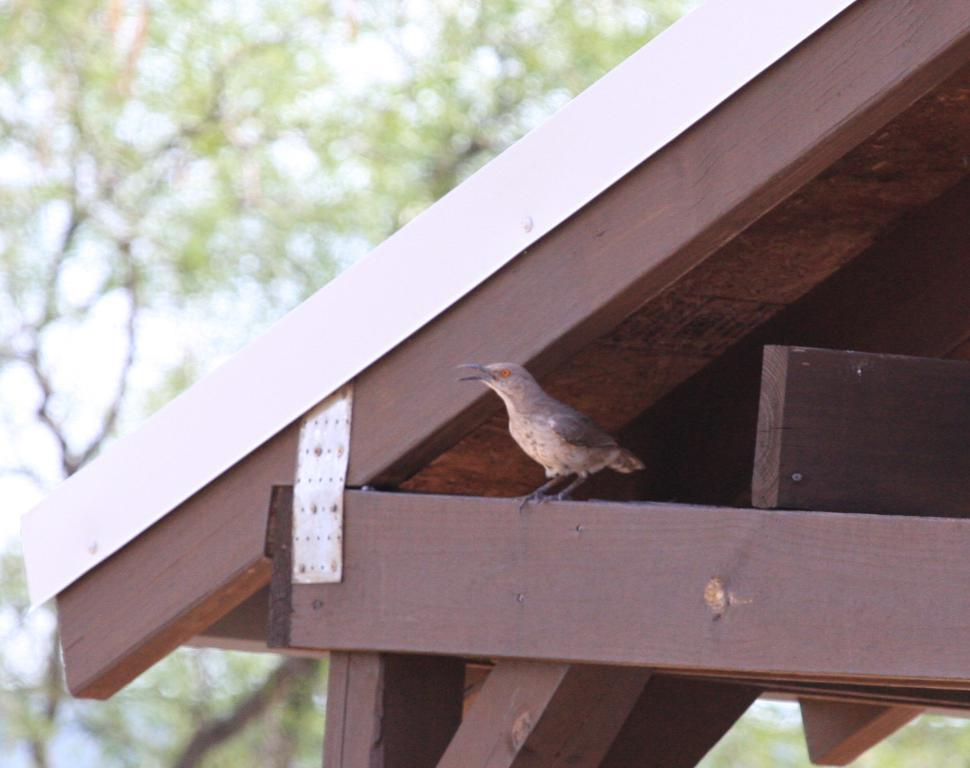What type of animal can be seen in the image? There is a bird in the image. Where is the bird located? The bird is standing on a wooden roof. What kind of structure does the wooden roof belong to? The wooden roof belongs to a house. What can be seen in the background of the image? There is a tree in the background of the image. What type of hammer is the bird using to fix the roof in the image? There is no hammer present in the image, and the bird is not shown using any tools. 